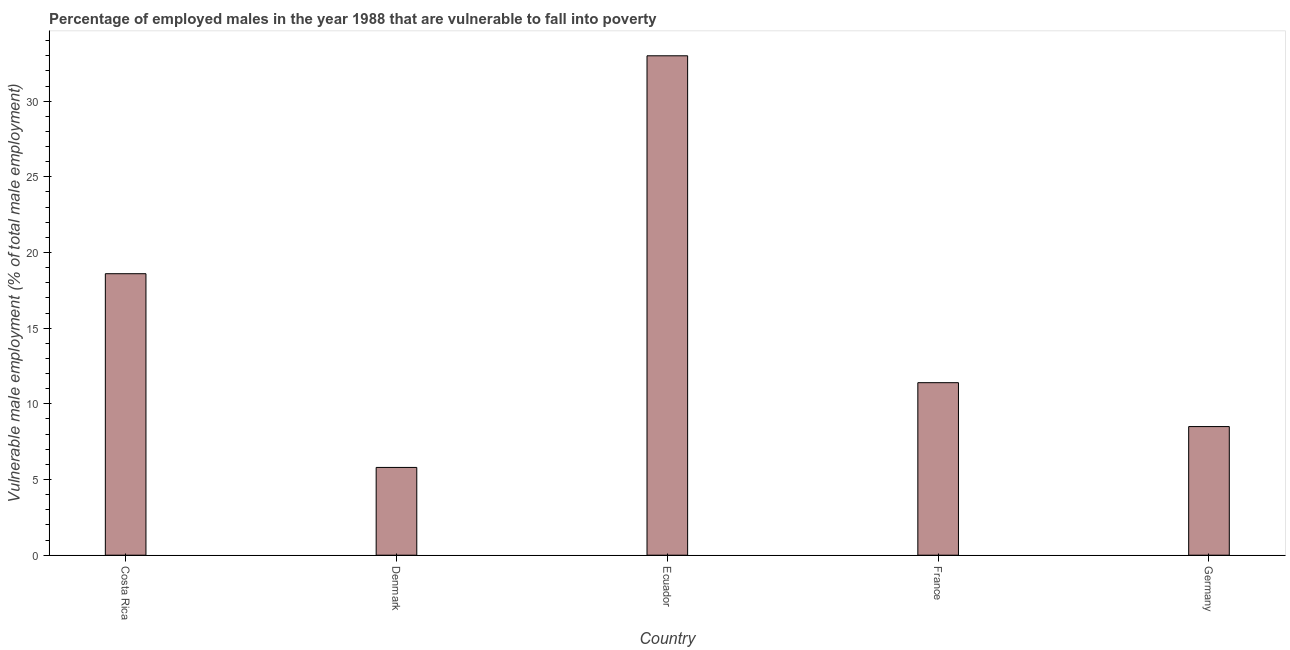Does the graph contain grids?
Keep it short and to the point. No. What is the title of the graph?
Ensure brevity in your answer.  Percentage of employed males in the year 1988 that are vulnerable to fall into poverty. What is the label or title of the Y-axis?
Provide a short and direct response. Vulnerable male employment (% of total male employment). What is the percentage of employed males who are vulnerable to fall into poverty in Costa Rica?
Provide a short and direct response. 18.6. Across all countries, what is the maximum percentage of employed males who are vulnerable to fall into poverty?
Your response must be concise. 33. Across all countries, what is the minimum percentage of employed males who are vulnerable to fall into poverty?
Your answer should be very brief. 5.8. In which country was the percentage of employed males who are vulnerable to fall into poverty maximum?
Your response must be concise. Ecuador. What is the sum of the percentage of employed males who are vulnerable to fall into poverty?
Give a very brief answer. 77.3. What is the average percentage of employed males who are vulnerable to fall into poverty per country?
Keep it short and to the point. 15.46. What is the median percentage of employed males who are vulnerable to fall into poverty?
Your answer should be compact. 11.4. What is the ratio of the percentage of employed males who are vulnerable to fall into poverty in Ecuador to that in Germany?
Make the answer very short. 3.88. What is the difference between the highest and the lowest percentage of employed males who are vulnerable to fall into poverty?
Keep it short and to the point. 27.2. How many bars are there?
Offer a terse response. 5. How many countries are there in the graph?
Provide a succinct answer. 5. What is the difference between two consecutive major ticks on the Y-axis?
Provide a short and direct response. 5. What is the Vulnerable male employment (% of total male employment) in Costa Rica?
Provide a succinct answer. 18.6. What is the Vulnerable male employment (% of total male employment) in Denmark?
Offer a terse response. 5.8. What is the Vulnerable male employment (% of total male employment) in Ecuador?
Your answer should be compact. 33. What is the Vulnerable male employment (% of total male employment) of France?
Your answer should be very brief. 11.4. What is the difference between the Vulnerable male employment (% of total male employment) in Costa Rica and Denmark?
Provide a short and direct response. 12.8. What is the difference between the Vulnerable male employment (% of total male employment) in Costa Rica and Ecuador?
Your answer should be very brief. -14.4. What is the difference between the Vulnerable male employment (% of total male employment) in Denmark and Ecuador?
Offer a very short reply. -27.2. What is the difference between the Vulnerable male employment (% of total male employment) in Ecuador and France?
Offer a terse response. 21.6. What is the difference between the Vulnerable male employment (% of total male employment) in Ecuador and Germany?
Keep it short and to the point. 24.5. What is the difference between the Vulnerable male employment (% of total male employment) in France and Germany?
Your response must be concise. 2.9. What is the ratio of the Vulnerable male employment (% of total male employment) in Costa Rica to that in Denmark?
Provide a short and direct response. 3.21. What is the ratio of the Vulnerable male employment (% of total male employment) in Costa Rica to that in Ecuador?
Provide a short and direct response. 0.56. What is the ratio of the Vulnerable male employment (% of total male employment) in Costa Rica to that in France?
Offer a very short reply. 1.63. What is the ratio of the Vulnerable male employment (% of total male employment) in Costa Rica to that in Germany?
Ensure brevity in your answer.  2.19. What is the ratio of the Vulnerable male employment (% of total male employment) in Denmark to that in Ecuador?
Your answer should be compact. 0.18. What is the ratio of the Vulnerable male employment (% of total male employment) in Denmark to that in France?
Offer a terse response. 0.51. What is the ratio of the Vulnerable male employment (% of total male employment) in Denmark to that in Germany?
Provide a short and direct response. 0.68. What is the ratio of the Vulnerable male employment (% of total male employment) in Ecuador to that in France?
Your response must be concise. 2.9. What is the ratio of the Vulnerable male employment (% of total male employment) in Ecuador to that in Germany?
Offer a very short reply. 3.88. What is the ratio of the Vulnerable male employment (% of total male employment) in France to that in Germany?
Offer a terse response. 1.34. 